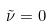Convert formula to latex. <formula><loc_0><loc_0><loc_500><loc_500>\tilde { \nu } = 0</formula> 